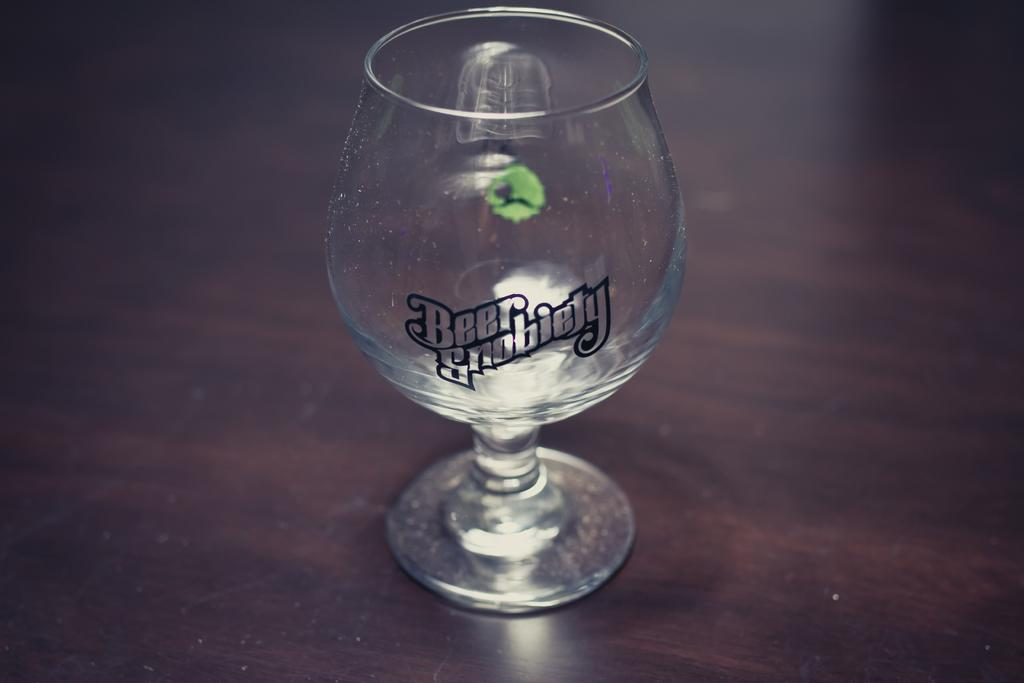What object can be seen in the image? There is a glass in the image. What is unique about the glass in the image? There is text written on the glass. What type of instrument is being played in the image? There is no instrument present in the image; it only features a glass with text on it. How many scales can be seen in the image? There are no scales present in the image; it only features a glass with text on it. 